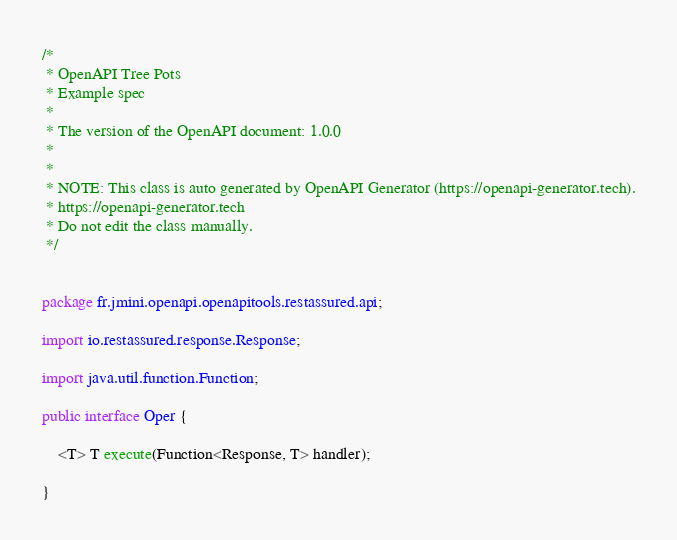<code> <loc_0><loc_0><loc_500><loc_500><_Java_>/*
 * OpenAPI Tree Pots
 * Example spec
 *
 * The version of the OpenAPI document: 1.0.0
 * 
 *
 * NOTE: This class is auto generated by OpenAPI Generator (https://openapi-generator.tech).
 * https://openapi-generator.tech
 * Do not edit the class manually.
 */


package fr.jmini.openapi.openapitools.restassured.api;

import io.restassured.response.Response;

import java.util.function.Function;

public interface Oper {

    <T> T execute(Function<Response, T> handler);

}
</code> 